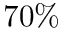<formula> <loc_0><loc_0><loc_500><loc_500>7 0 \%</formula> 